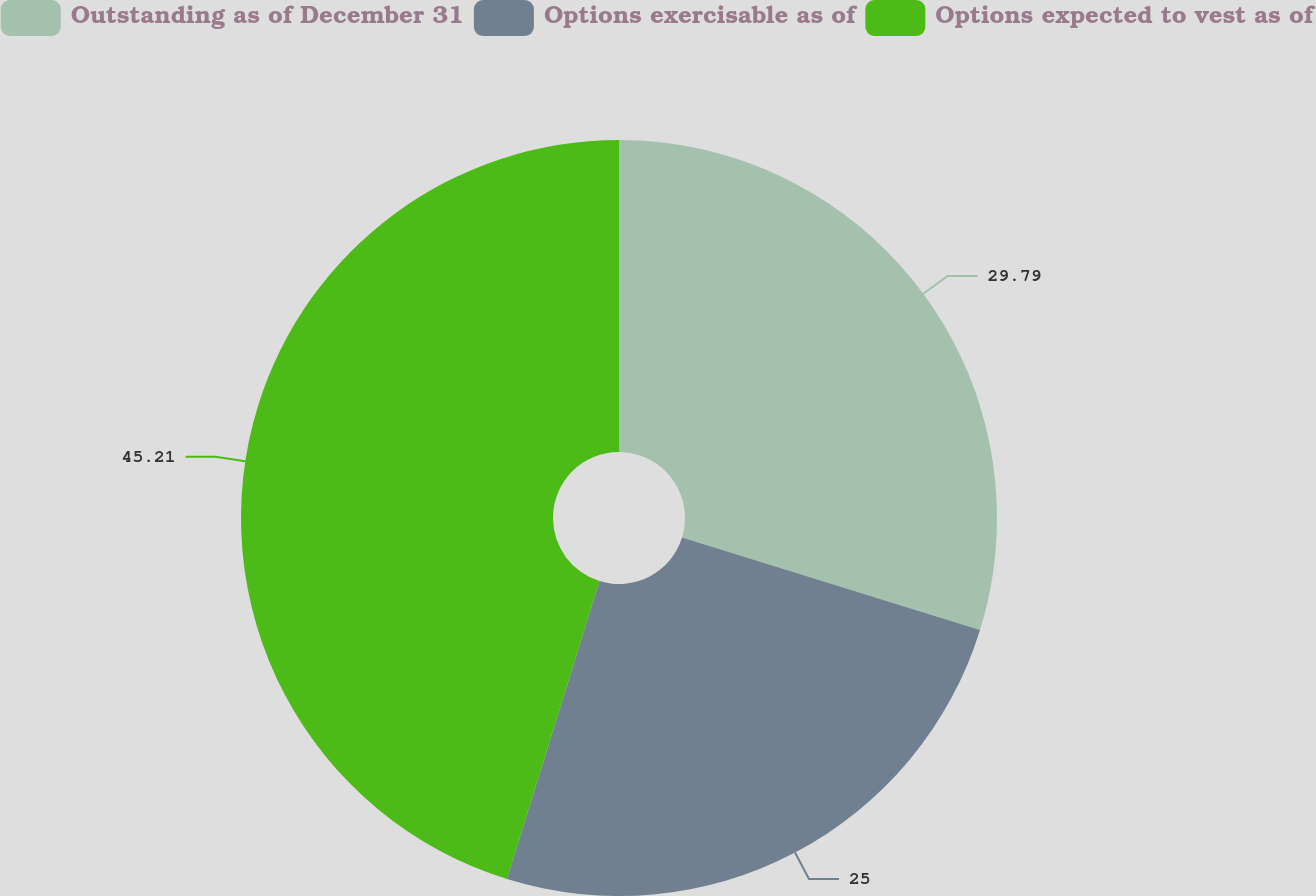Convert chart. <chart><loc_0><loc_0><loc_500><loc_500><pie_chart><fcel>Outstanding as of December 31<fcel>Options exercisable as of<fcel>Options expected to vest as of<nl><fcel>29.79%<fcel>25.0%<fcel>45.21%<nl></chart> 